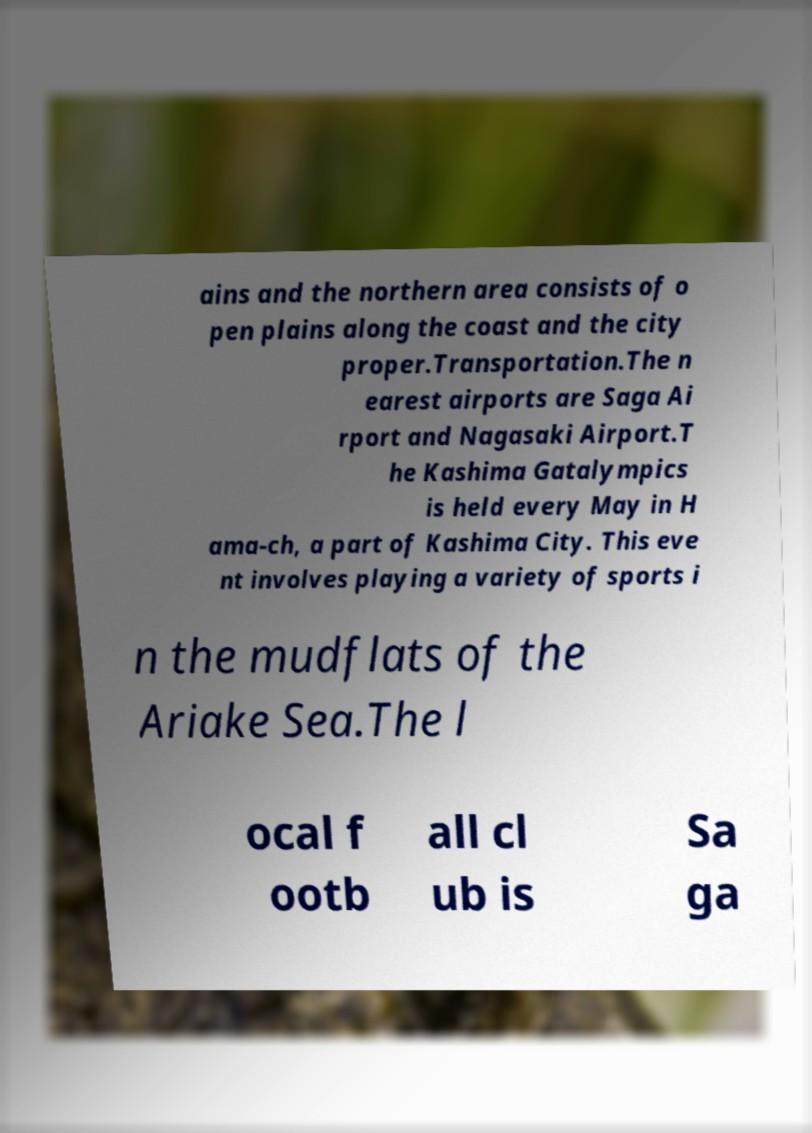Please identify and transcribe the text found in this image. ains and the northern area consists of o pen plains along the coast and the city proper.Transportation.The n earest airports are Saga Ai rport and Nagasaki Airport.T he Kashima Gatalympics is held every May in H ama-ch, a part of Kashima City. This eve nt involves playing a variety of sports i n the mudflats of the Ariake Sea.The l ocal f ootb all cl ub is Sa ga 